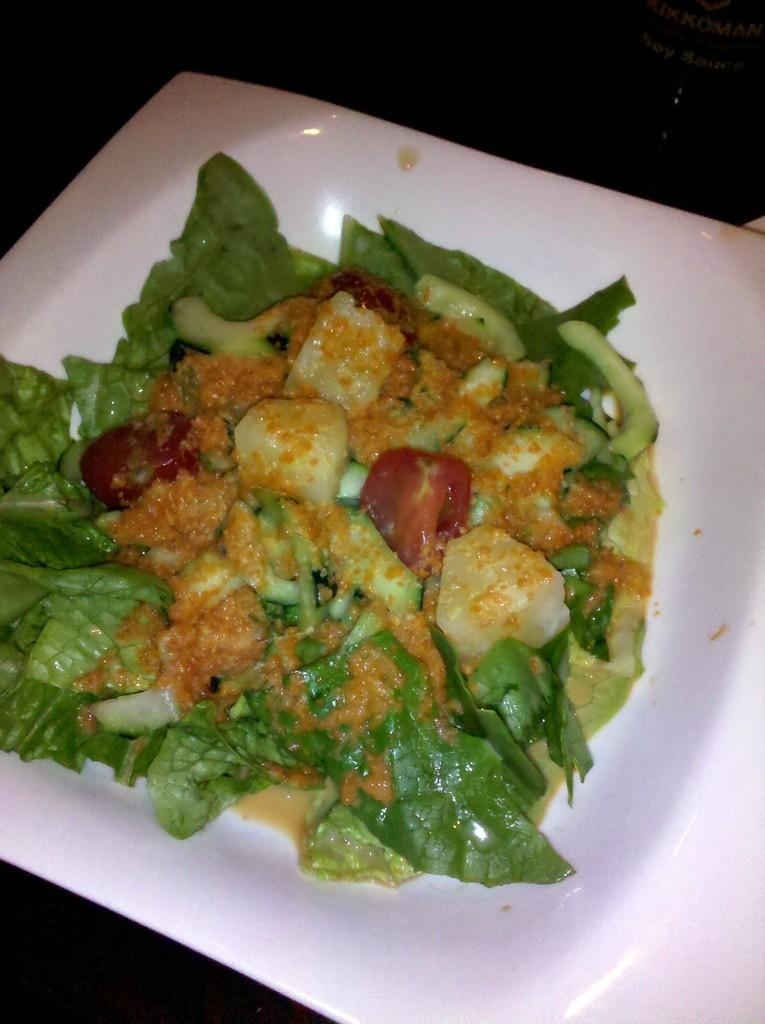What type of food is visible in the image? There is green vegetable food in the image. How is the green vegetable food presented? The green vegetable food is placed on a white plate. What type of meat is being served on a bun in the image? There is no meat or bun present in the image; it only features green vegetable food on a white plate. 